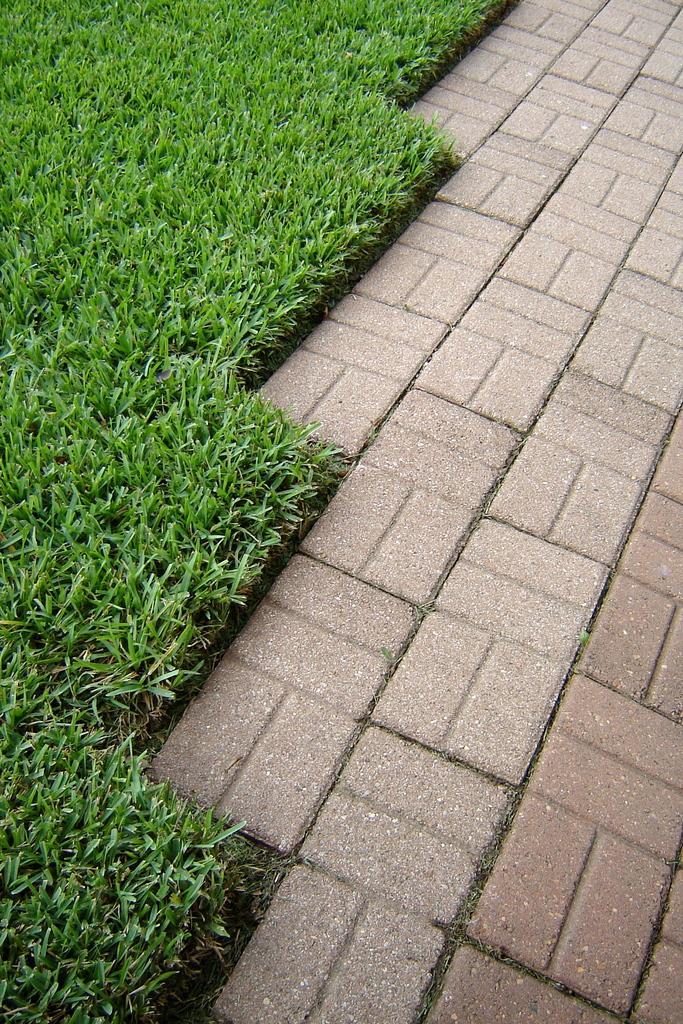Please provide a concise description of this image. Here in this picture on the left side we can see grass present on the ground and on the right side we can see a walking path present. 